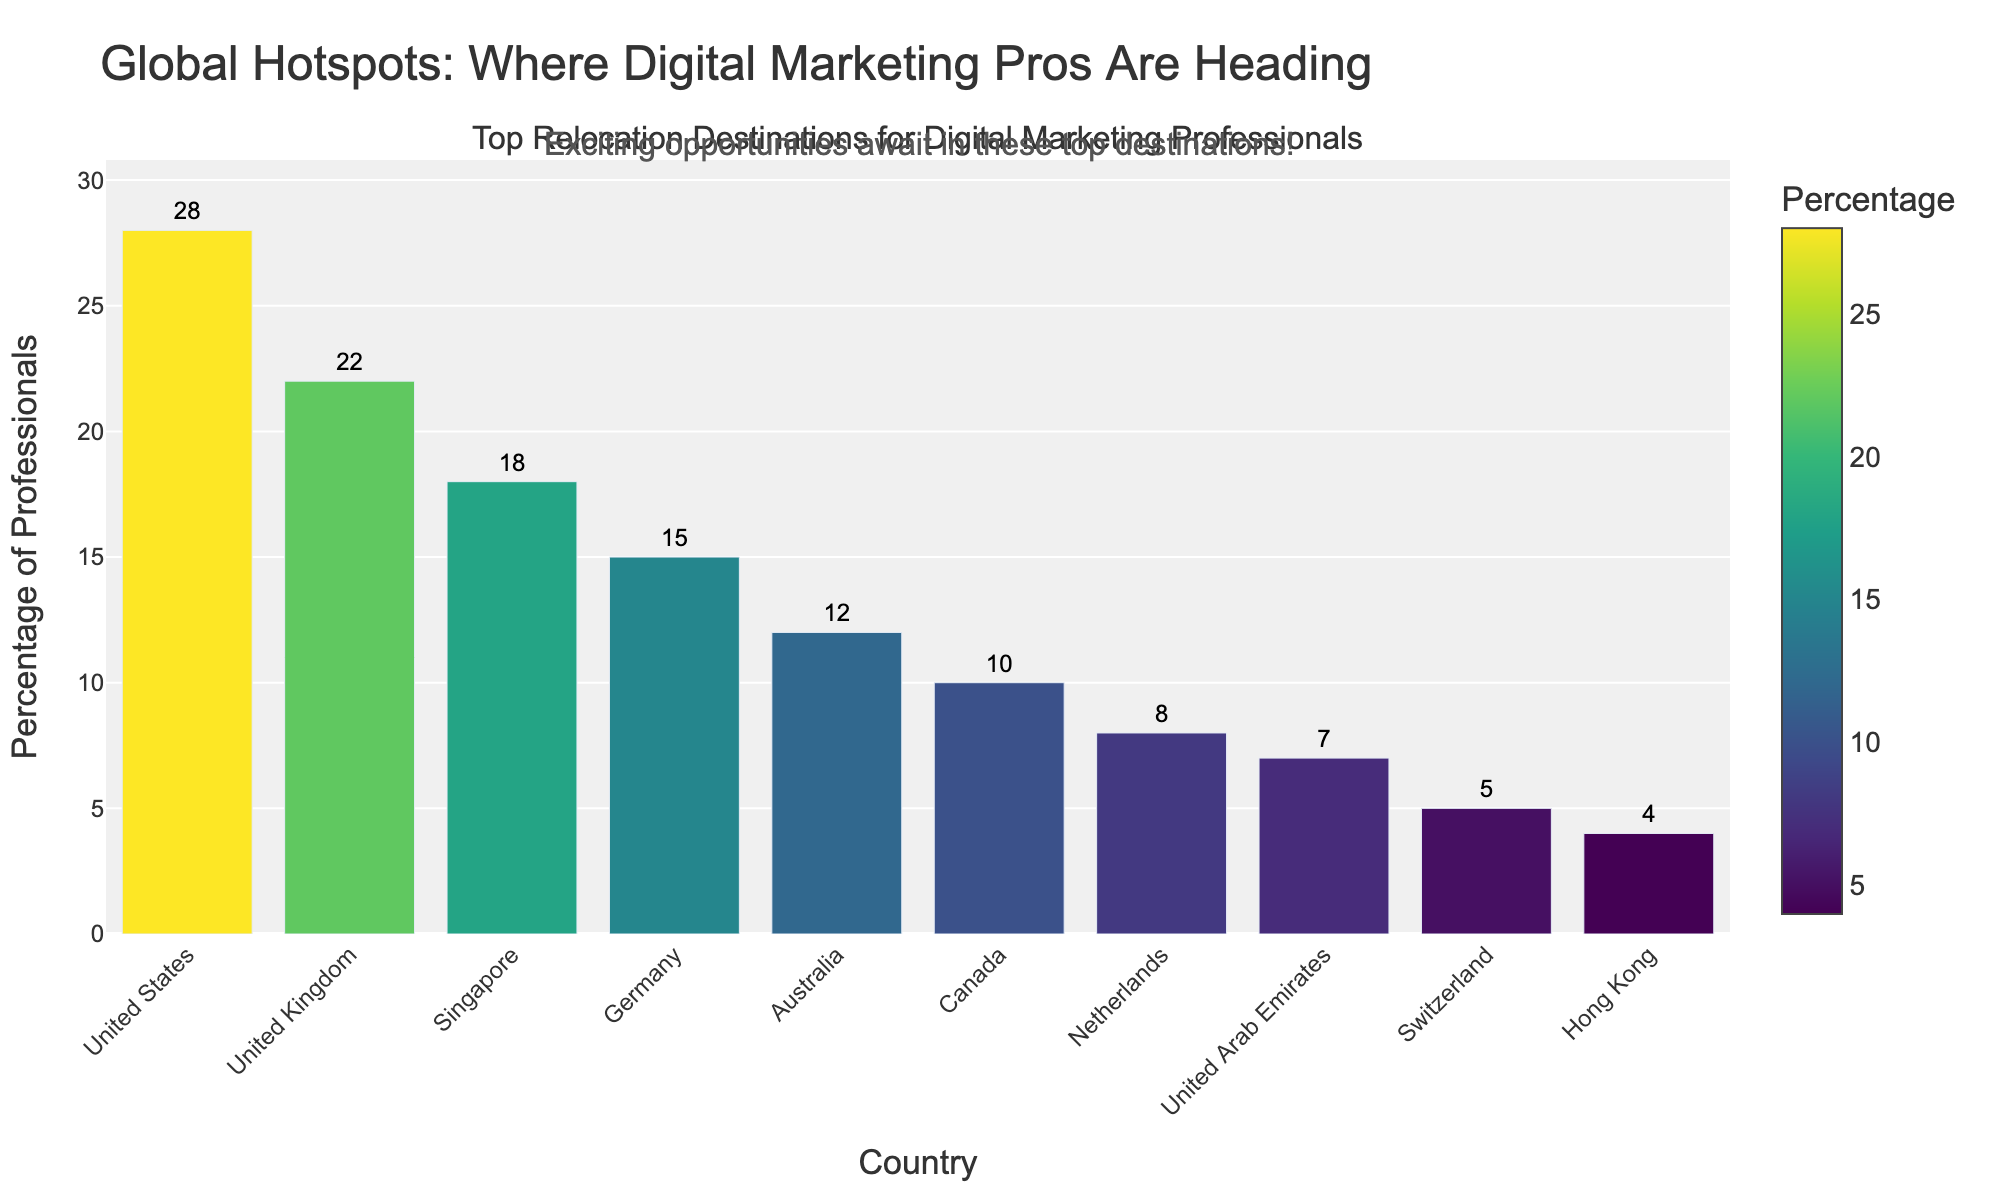Which country is the most popular destination for digital marketing professionals? The bar representing the United States is the tallest, indicating it has the highest percentage.
Answer: United States Which two countries have the closest percentages of digital marketing professionals relocating? By comparing the heights of the bars, the percentages for Canada (10%) and Netherlands (8%) are very close.
Answer: Canada and Netherlands What is the total percentage of digital marketing professionals relocating to Germany, Australia, and Canada combined? Sum the percentages: Germany (15%) + Australia (12%) + Canada (10%) = 37%
Answer: 37% How many more professionals relocate to the United States compared to Switzerland? Subtract the percentage for Switzerland (5%) from the United States (28%): 28% - 5% = 23%
Answer: 23% Which country has the lowest percentage of digital marketing professionals relocating, and what is that percentage? The shortest bar represents Hong Kong, with a percentage of 4%.
Answer: Hong Kong, 4% How do the relocation percentages for the United Kingdom and Singapore compare? The bar for the United Kingdom (22%) is slightly higher than that of Singapore (18%).
Answer: United Kingdom is higher than Singapore What is the average percentage of digital marketing professionals relocating to the top 5 countries? Sum the percentages of the top 5 countries: 28% (United States) + 22% (United Kingdom) + 18% (Singapore) + 15% (Germany) + 12% (Australia) = 95%. Divide by 5: 95% / 5 = 19%.
Answer: 19% Which countries have relocation percentages below 10%, and what are the exact percentages? Identify bars below the 10% mark: Netherlands (8%), United Arab Emirates (7%), Switzerland (5%), and Hong Kong (4%).
Answer: Netherlands (8%), United Arab Emirates (7%), Switzerland (5%), Hong Kong (4%) What is the difference in the relocation percentage between the second highest and the second lowest country? Subtract the percentage for the second lowest, United Arab Emirates (7%), from the second highest, United Kingdom (22%): 22% - 7% = 15%
Answer: 15% Which country has slightly more professionals relocating to it: Netherlands or United Arab Emirates? The bar for Netherlands is slightly taller than the bar for United Arab Emirates. The exact percentages are Netherlands (8%) and United Arab Emirates (7%).
Answer: Netherlands 